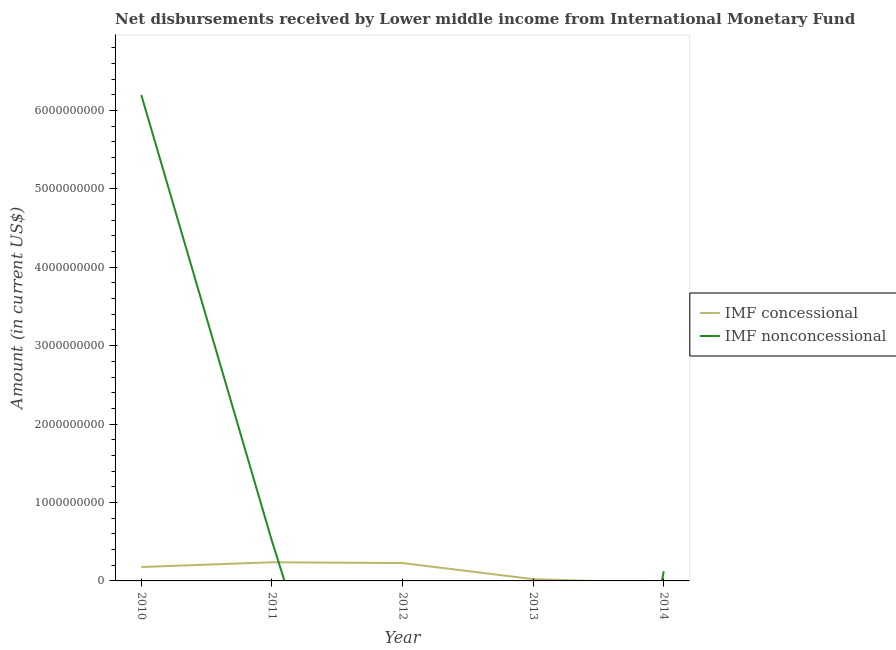What is the net non concessional disbursements from imf in 2010?
Your answer should be compact. 6.20e+09. Across all years, what is the maximum net concessional disbursements from imf?
Give a very brief answer. 2.38e+08. Across all years, what is the minimum net concessional disbursements from imf?
Offer a very short reply. 0. What is the total net non concessional disbursements from imf in the graph?
Give a very brief answer. 6.83e+09. What is the difference between the net concessional disbursements from imf in 2012 and that in 2013?
Keep it short and to the point. 2.05e+08. What is the difference between the net concessional disbursements from imf in 2013 and the net non concessional disbursements from imf in 2014?
Your response must be concise. -9.95e+07. What is the average net non concessional disbursements from imf per year?
Make the answer very short. 1.37e+09. In the year 2010, what is the difference between the net non concessional disbursements from imf and net concessional disbursements from imf?
Give a very brief answer. 6.02e+09. In how many years, is the net concessional disbursements from imf greater than 4200000000 US$?
Your answer should be compact. 0. What is the ratio of the net concessional disbursements from imf in 2010 to that in 2012?
Provide a short and direct response. 0.78. Is the net non concessional disbursements from imf in 2011 less than that in 2014?
Keep it short and to the point. No. What is the difference between the highest and the second highest net non concessional disbursements from imf?
Your answer should be very brief. 5.69e+09. What is the difference between the highest and the lowest net concessional disbursements from imf?
Offer a very short reply. 2.38e+08. Is the sum of the net non concessional disbursements from imf in 2010 and 2011 greater than the maximum net concessional disbursements from imf across all years?
Your answer should be compact. Yes. Is the net non concessional disbursements from imf strictly greater than the net concessional disbursements from imf over the years?
Provide a short and direct response. No. Is the net concessional disbursements from imf strictly less than the net non concessional disbursements from imf over the years?
Ensure brevity in your answer.  No. Are the values on the major ticks of Y-axis written in scientific E-notation?
Ensure brevity in your answer.  No. Does the graph contain any zero values?
Provide a succinct answer. Yes. Where does the legend appear in the graph?
Your answer should be compact. Center right. What is the title of the graph?
Provide a succinct answer. Net disbursements received by Lower middle income from International Monetary Fund. Does "Fertility rate" appear as one of the legend labels in the graph?
Provide a short and direct response. No. What is the label or title of the X-axis?
Your response must be concise. Year. What is the label or title of the Y-axis?
Provide a succinct answer. Amount (in current US$). What is the Amount (in current US$) in IMF concessional in 2010?
Offer a terse response. 1.77e+08. What is the Amount (in current US$) of IMF nonconcessional in 2010?
Keep it short and to the point. 6.20e+09. What is the Amount (in current US$) of IMF concessional in 2011?
Ensure brevity in your answer.  2.38e+08. What is the Amount (in current US$) in IMF nonconcessional in 2011?
Offer a terse response. 5.10e+08. What is the Amount (in current US$) in IMF concessional in 2012?
Offer a very short reply. 2.28e+08. What is the Amount (in current US$) of IMF concessional in 2013?
Offer a terse response. 2.32e+07. What is the Amount (in current US$) in IMF nonconcessional in 2013?
Your answer should be compact. 0. What is the Amount (in current US$) of IMF nonconcessional in 2014?
Ensure brevity in your answer.  1.23e+08. Across all years, what is the maximum Amount (in current US$) in IMF concessional?
Your response must be concise. 2.38e+08. Across all years, what is the maximum Amount (in current US$) in IMF nonconcessional?
Make the answer very short. 6.20e+09. Across all years, what is the minimum Amount (in current US$) in IMF concessional?
Offer a very short reply. 0. Across all years, what is the minimum Amount (in current US$) in IMF nonconcessional?
Give a very brief answer. 0. What is the total Amount (in current US$) in IMF concessional in the graph?
Provide a succinct answer. 6.66e+08. What is the total Amount (in current US$) in IMF nonconcessional in the graph?
Your answer should be very brief. 6.83e+09. What is the difference between the Amount (in current US$) in IMF concessional in 2010 and that in 2011?
Provide a short and direct response. -6.04e+07. What is the difference between the Amount (in current US$) of IMF nonconcessional in 2010 and that in 2011?
Offer a very short reply. 5.69e+09. What is the difference between the Amount (in current US$) of IMF concessional in 2010 and that in 2012?
Give a very brief answer. -5.05e+07. What is the difference between the Amount (in current US$) in IMF concessional in 2010 and that in 2013?
Make the answer very short. 1.54e+08. What is the difference between the Amount (in current US$) in IMF nonconcessional in 2010 and that in 2014?
Provide a short and direct response. 6.07e+09. What is the difference between the Amount (in current US$) of IMF concessional in 2011 and that in 2012?
Give a very brief answer. 9.87e+06. What is the difference between the Amount (in current US$) of IMF concessional in 2011 and that in 2013?
Ensure brevity in your answer.  2.14e+08. What is the difference between the Amount (in current US$) in IMF nonconcessional in 2011 and that in 2014?
Give a very brief answer. 3.88e+08. What is the difference between the Amount (in current US$) in IMF concessional in 2012 and that in 2013?
Your response must be concise. 2.05e+08. What is the difference between the Amount (in current US$) in IMF concessional in 2010 and the Amount (in current US$) in IMF nonconcessional in 2011?
Ensure brevity in your answer.  -3.33e+08. What is the difference between the Amount (in current US$) of IMF concessional in 2010 and the Amount (in current US$) of IMF nonconcessional in 2014?
Offer a terse response. 5.46e+07. What is the difference between the Amount (in current US$) in IMF concessional in 2011 and the Amount (in current US$) in IMF nonconcessional in 2014?
Your answer should be very brief. 1.15e+08. What is the difference between the Amount (in current US$) in IMF concessional in 2012 and the Amount (in current US$) in IMF nonconcessional in 2014?
Offer a terse response. 1.05e+08. What is the difference between the Amount (in current US$) in IMF concessional in 2013 and the Amount (in current US$) in IMF nonconcessional in 2014?
Your answer should be very brief. -9.95e+07. What is the average Amount (in current US$) of IMF concessional per year?
Your answer should be very brief. 1.33e+08. What is the average Amount (in current US$) of IMF nonconcessional per year?
Ensure brevity in your answer.  1.37e+09. In the year 2010, what is the difference between the Amount (in current US$) of IMF concessional and Amount (in current US$) of IMF nonconcessional?
Offer a very short reply. -6.02e+09. In the year 2011, what is the difference between the Amount (in current US$) of IMF concessional and Amount (in current US$) of IMF nonconcessional?
Provide a short and direct response. -2.73e+08. What is the ratio of the Amount (in current US$) of IMF concessional in 2010 to that in 2011?
Make the answer very short. 0.75. What is the ratio of the Amount (in current US$) in IMF nonconcessional in 2010 to that in 2011?
Your response must be concise. 12.14. What is the ratio of the Amount (in current US$) of IMF concessional in 2010 to that in 2012?
Make the answer very short. 0.78. What is the ratio of the Amount (in current US$) of IMF concessional in 2010 to that in 2013?
Keep it short and to the point. 7.65. What is the ratio of the Amount (in current US$) in IMF nonconcessional in 2010 to that in 2014?
Your answer should be compact. 50.51. What is the ratio of the Amount (in current US$) of IMF concessional in 2011 to that in 2012?
Provide a short and direct response. 1.04. What is the ratio of the Amount (in current US$) of IMF concessional in 2011 to that in 2013?
Offer a very short reply. 10.26. What is the ratio of the Amount (in current US$) in IMF nonconcessional in 2011 to that in 2014?
Your response must be concise. 4.16. What is the ratio of the Amount (in current US$) in IMF concessional in 2012 to that in 2013?
Provide a short and direct response. 9.83. What is the difference between the highest and the second highest Amount (in current US$) in IMF concessional?
Offer a terse response. 9.87e+06. What is the difference between the highest and the second highest Amount (in current US$) of IMF nonconcessional?
Make the answer very short. 5.69e+09. What is the difference between the highest and the lowest Amount (in current US$) of IMF concessional?
Offer a very short reply. 2.38e+08. What is the difference between the highest and the lowest Amount (in current US$) of IMF nonconcessional?
Ensure brevity in your answer.  6.20e+09. 